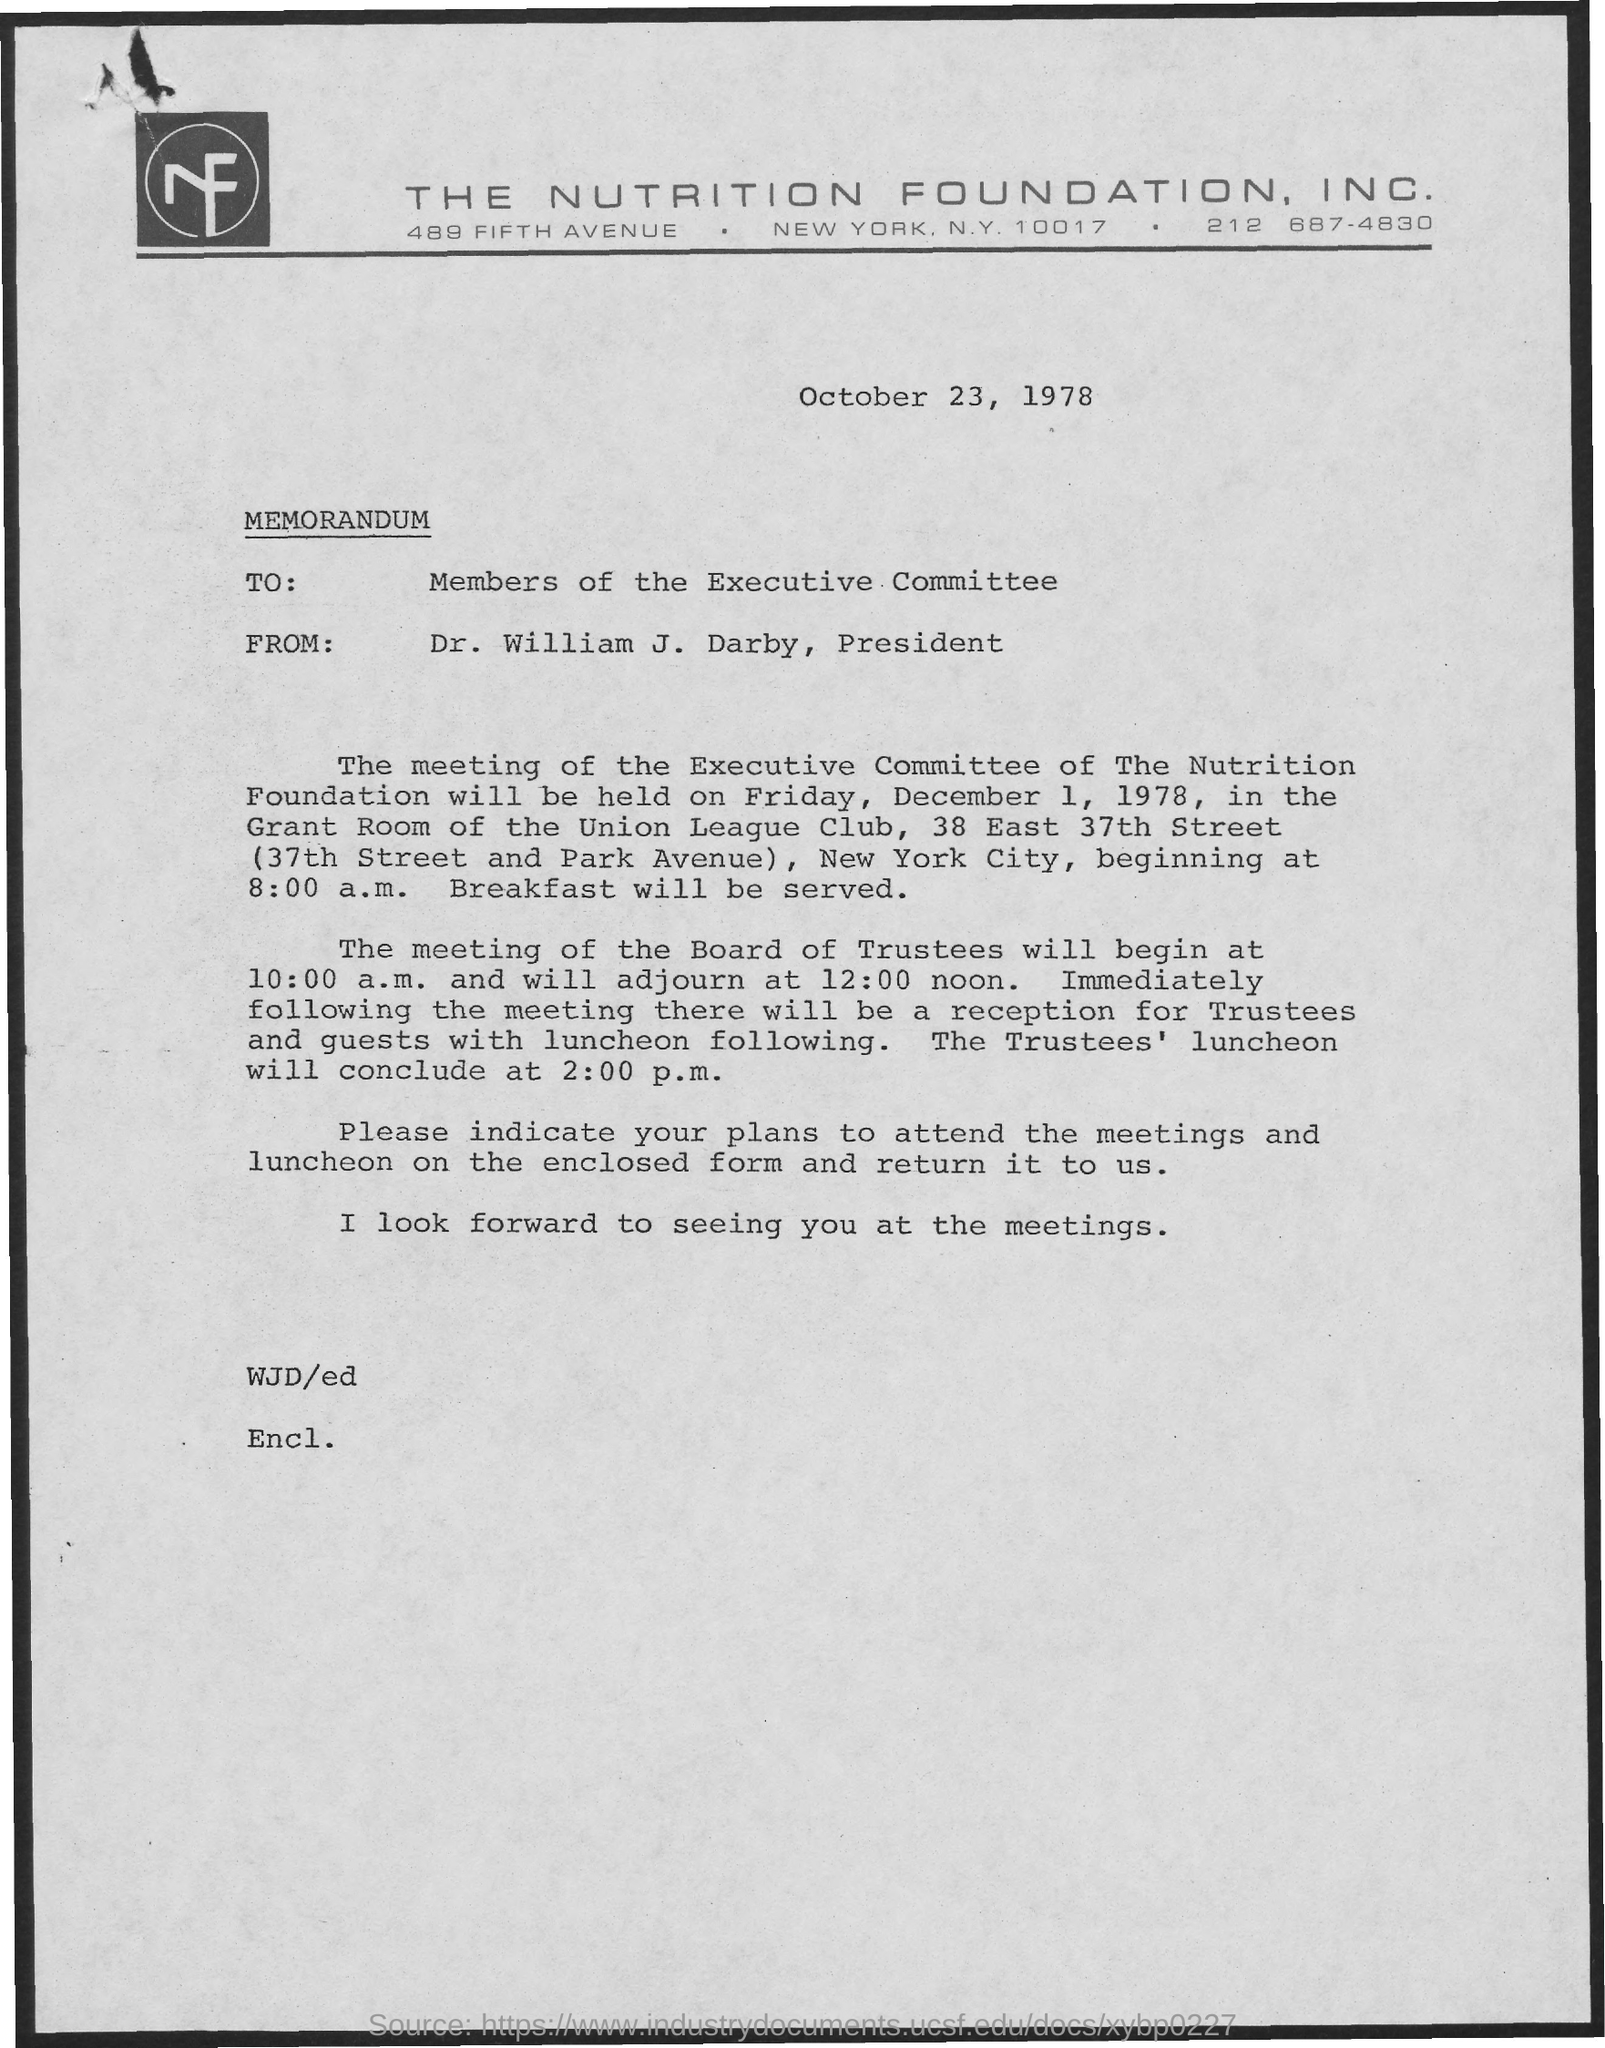Give some essential details in this illustration. The name of the company is THE NUTRITION FOUNDATION, INC. The memorandum is addressed to the members of the Executive Committee. The memorandum is from Dr. William J. Darby, the President. The memorandum is dated October 23, 1978. 